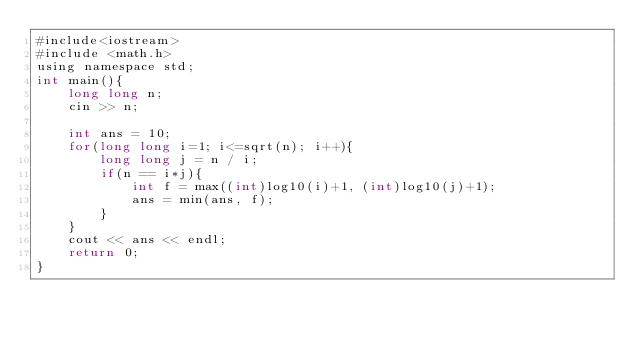<code> <loc_0><loc_0><loc_500><loc_500><_Java_>#include<iostream>
#include <math.h>
using namespace std;
int main(){
    long long n;
    cin >> n;

    int ans = 10;
    for(long long i=1; i<=sqrt(n); i++){
        long long j = n / i;
        if(n == i*j){
            int f = max((int)log10(i)+1, (int)log10(j)+1);
            ans = min(ans, f);
        }
    }
    cout << ans << endl;
    return 0;
}</code> 